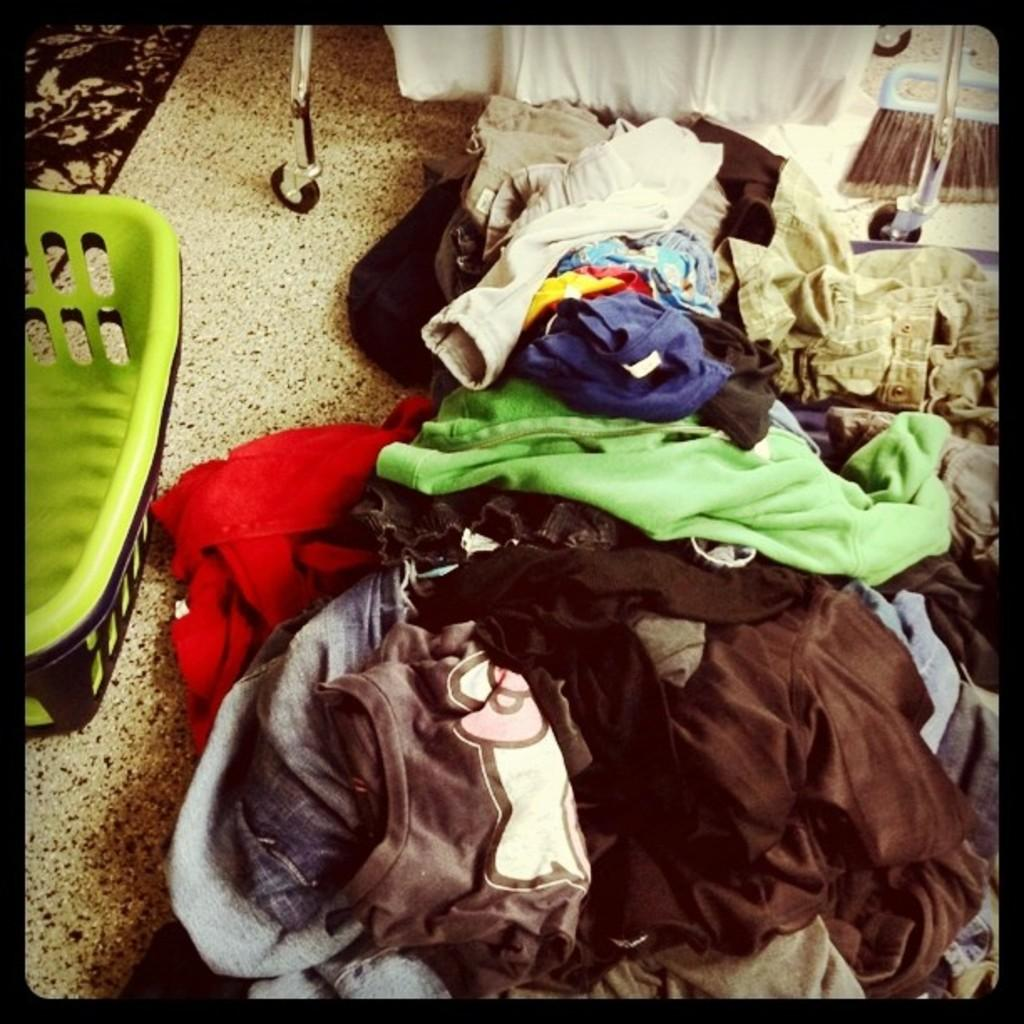What is on the floor in the image? There are clothes on the floor in the image. Where is the basket located in the image? The basket is on the left side of the image. How many yams are in the basket in the image? There is no yam present in the image; the basket is empty. What type of corn is visible on the floor in the image? There is no corn present in the image; only clothes are on the floor. 